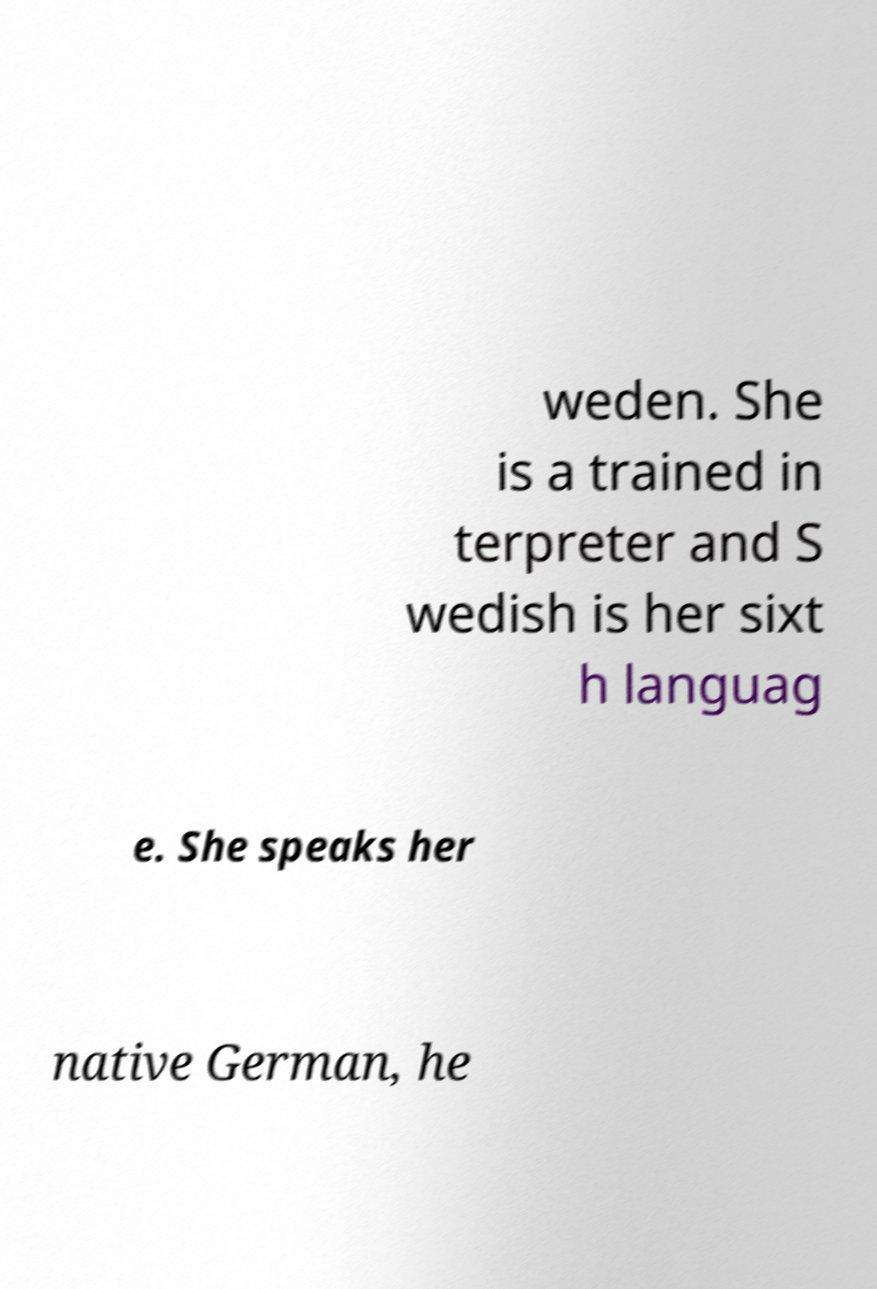What messages or text are displayed in this image? I need them in a readable, typed format. weden. She is a trained in terpreter and S wedish is her sixt h languag e. She speaks her native German, he 